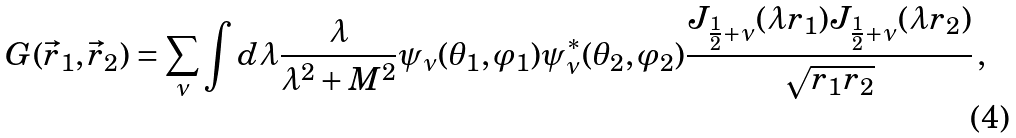<formula> <loc_0><loc_0><loc_500><loc_500>G ( \vec { r } _ { 1 } , \vec { r } _ { 2 } ) = \sum _ { \nu } \int d \lambda \frac { \lambda } { \lambda ^ { 2 } + M ^ { 2 } } \psi _ { \nu } ( \theta _ { 1 } , \varphi _ { 1 } ) \psi ^ { * } _ { \nu } ( \theta _ { 2 } , \varphi _ { 2 } ) \frac { J _ { \frac { 1 } { 2 } + \nu } ( \lambda r _ { 1 } ) J _ { \frac { 1 } { 2 } + \nu } ( \lambda r _ { 2 } ) } { \sqrt { r _ { 1 } r _ { 2 } } } \, ,</formula> 